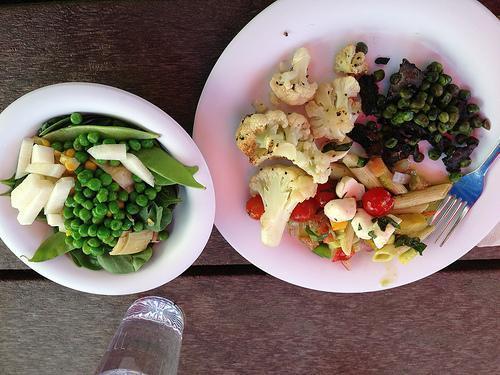How many dishes?
Give a very brief answer. 2. 